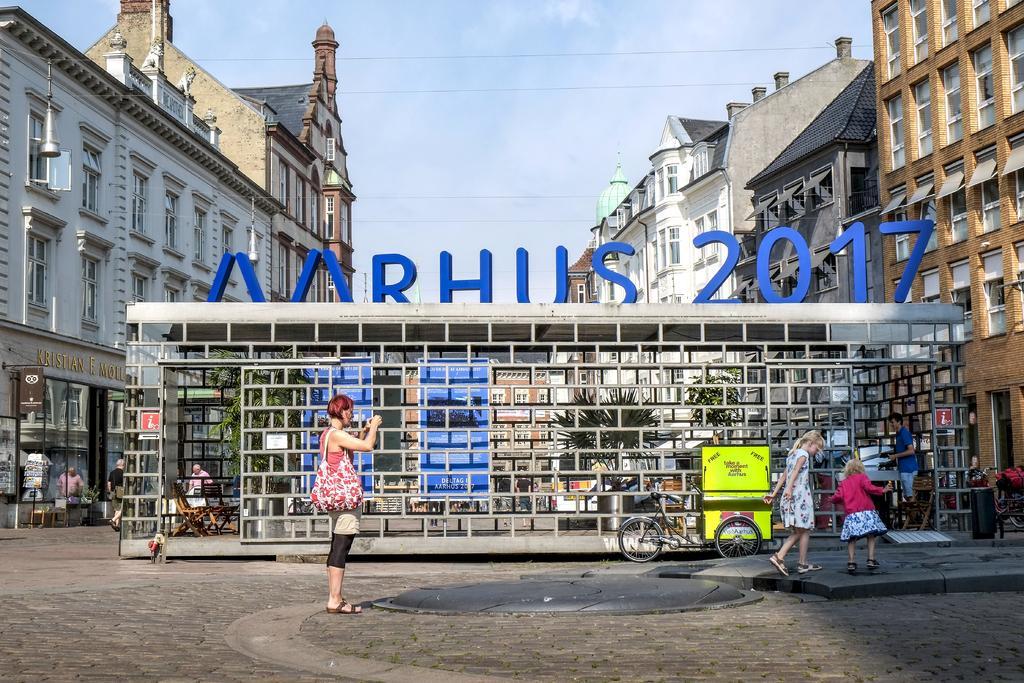Could you give a brief overview of what you see in this image? In this image I can see few buildings, windows, plants, chairs, few vehicles, stores, few people, one person is holding something and few objects around. The sky is in blue and white color. 